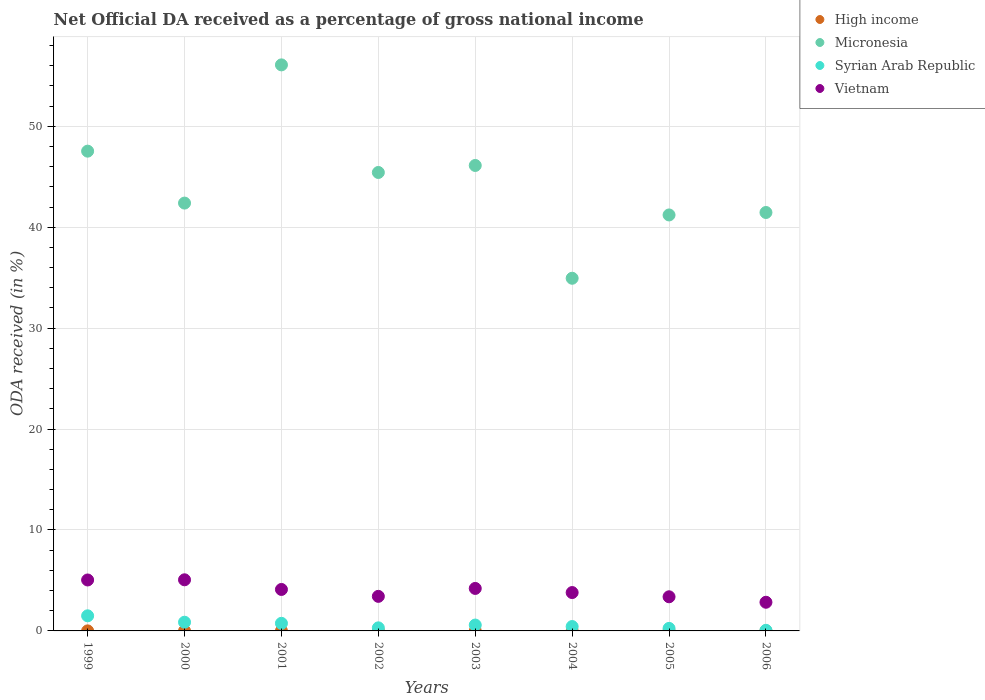Is the number of dotlines equal to the number of legend labels?
Ensure brevity in your answer.  Yes. What is the net official DA received in Syrian Arab Republic in 2002?
Make the answer very short. 0.3. Across all years, what is the maximum net official DA received in Vietnam?
Your response must be concise. 5.07. Across all years, what is the minimum net official DA received in Micronesia?
Give a very brief answer. 34.94. In which year was the net official DA received in High income minimum?
Your answer should be compact. 2005. What is the total net official DA received in Syrian Arab Republic in the graph?
Make the answer very short. 4.74. What is the difference between the net official DA received in Syrian Arab Republic in 2003 and that in 2004?
Make the answer very short. 0.15. What is the difference between the net official DA received in Vietnam in 2005 and the net official DA received in Syrian Arab Republic in 2000?
Keep it short and to the point. 2.52. What is the average net official DA received in Vietnam per year?
Your answer should be compact. 3.98. In the year 2000, what is the difference between the net official DA received in Micronesia and net official DA received in Vietnam?
Make the answer very short. 37.32. In how many years, is the net official DA received in Micronesia greater than 24 %?
Offer a very short reply. 8. What is the ratio of the net official DA received in Vietnam in 2001 to that in 2004?
Ensure brevity in your answer.  1.08. Is the net official DA received in Vietnam in 1999 less than that in 2005?
Give a very brief answer. No. What is the difference between the highest and the second highest net official DA received in Syrian Arab Republic?
Make the answer very short. 0.64. What is the difference between the highest and the lowest net official DA received in Micronesia?
Keep it short and to the point. 21.14. Is the sum of the net official DA received in Micronesia in 2000 and 2003 greater than the maximum net official DA received in Syrian Arab Republic across all years?
Make the answer very short. Yes. Is it the case that in every year, the sum of the net official DA received in High income and net official DA received in Micronesia  is greater than the sum of net official DA received in Syrian Arab Republic and net official DA received in Vietnam?
Ensure brevity in your answer.  Yes. Is the net official DA received in High income strictly greater than the net official DA received in Syrian Arab Republic over the years?
Offer a terse response. No. How many dotlines are there?
Provide a succinct answer. 4. How many years are there in the graph?
Make the answer very short. 8. What is the difference between two consecutive major ticks on the Y-axis?
Your response must be concise. 10. Are the values on the major ticks of Y-axis written in scientific E-notation?
Keep it short and to the point. No. Does the graph contain any zero values?
Your response must be concise. No. What is the title of the graph?
Give a very brief answer. Net Official DA received as a percentage of gross national income. What is the label or title of the X-axis?
Provide a succinct answer. Years. What is the label or title of the Y-axis?
Ensure brevity in your answer.  ODA received (in %). What is the ODA received (in %) of High income in 1999?
Your answer should be very brief. 0. What is the ODA received (in %) in Micronesia in 1999?
Provide a short and direct response. 47.54. What is the ODA received (in %) of Syrian Arab Republic in 1999?
Ensure brevity in your answer.  1.5. What is the ODA received (in %) of Vietnam in 1999?
Offer a terse response. 5.05. What is the ODA received (in %) in High income in 2000?
Ensure brevity in your answer.  0. What is the ODA received (in %) of Micronesia in 2000?
Keep it short and to the point. 42.39. What is the ODA received (in %) of Syrian Arab Republic in 2000?
Your answer should be compact. 0.86. What is the ODA received (in %) of Vietnam in 2000?
Offer a terse response. 5.07. What is the ODA received (in %) in High income in 2001?
Provide a short and direct response. 0. What is the ODA received (in %) in Micronesia in 2001?
Your answer should be very brief. 56.08. What is the ODA received (in %) in Syrian Arab Republic in 2001?
Your answer should be compact. 0.75. What is the ODA received (in %) in Vietnam in 2001?
Your answer should be compact. 4.11. What is the ODA received (in %) of High income in 2002?
Your answer should be compact. 0. What is the ODA received (in %) of Micronesia in 2002?
Keep it short and to the point. 45.42. What is the ODA received (in %) of Syrian Arab Republic in 2002?
Make the answer very short. 0.3. What is the ODA received (in %) of Vietnam in 2002?
Keep it short and to the point. 3.42. What is the ODA received (in %) of High income in 2003?
Your answer should be very brief. 0. What is the ODA received (in %) of Micronesia in 2003?
Your answer should be compact. 46.12. What is the ODA received (in %) of Syrian Arab Republic in 2003?
Offer a very short reply. 0.58. What is the ODA received (in %) of Vietnam in 2003?
Give a very brief answer. 4.21. What is the ODA received (in %) of High income in 2004?
Provide a succinct answer. 0. What is the ODA received (in %) in Micronesia in 2004?
Your answer should be compact. 34.94. What is the ODA received (in %) of Syrian Arab Republic in 2004?
Ensure brevity in your answer.  0.43. What is the ODA received (in %) of Vietnam in 2004?
Keep it short and to the point. 3.8. What is the ODA received (in %) of High income in 2005?
Give a very brief answer. 0. What is the ODA received (in %) in Micronesia in 2005?
Your answer should be very brief. 41.21. What is the ODA received (in %) of Syrian Arab Republic in 2005?
Your response must be concise. 0.25. What is the ODA received (in %) of Vietnam in 2005?
Make the answer very short. 3.38. What is the ODA received (in %) in High income in 2006?
Offer a very short reply. 0. What is the ODA received (in %) of Micronesia in 2006?
Offer a terse response. 41.46. What is the ODA received (in %) in Syrian Arab Republic in 2006?
Provide a short and direct response. 0.06. What is the ODA received (in %) of Vietnam in 2006?
Ensure brevity in your answer.  2.84. Across all years, what is the maximum ODA received (in %) of High income?
Your answer should be compact. 0. Across all years, what is the maximum ODA received (in %) of Micronesia?
Offer a very short reply. 56.08. Across all years, what is the maximum ODA received (in %) in Syrian Arab Republic?
Provide a short and direct response. 1.5. Across all years, what is the maximum ODA received (in %) in Vietnam?
Your response must be concise. 5.07. Across all years, what is the minimum ODA received (in %) of High income?
Your response must be concise. 0. Across all years, what is the minimum ODA received (in %) of Micronesia?
Give a very brief answer. 34.94. Across all years, what is the minimum ODA received (in %) in Syrian Arab Republic?
Keep it short and to the point. 0.06. Across all years, what is the minimum ODA received (in %) in Vietnam?
Your answer should be compact. 2.84. What is the total ODA received (in %) of High income in the graph?
Give a very brief answer. 0.01. What is the total ODA received (in %) of Micronesia in the graph?
Provide a short and direct response. 355.16. What is the total ODA received (in %) in Syrian Arab Republic in the graph?
Give a very brief answer. 4.74. What is the total ODA received (in %) in Vietnam in the graph?
Offer a terse response. 31.88. What is the difference between the ODA received (in %) in High income in 1999 and that in 2000?
Provide a short and direct response. 0. What is the difference between the ODA received (in %) in Micronesia in 1999 and that in 2000?
Offer a very short reply. 5.15. What is the difference between the ODA received (in %) of Syrian Arab Republic in 1999 and that in 2000?
Make the answer very short. 0.64. What is the difference between the ODA received (in %) of Vietnam in 1999 and that in 2000?
Make the answer very short. -0.02. What is the difference between the ODA received (in %) in High income in 1999 and that in 2001?
Ensure brevity in your answer.  0. What is the difference between the ODA received (in %) of Micronesia in 1999 and that in 2001?
Give a very brief answer. -8.55. What is the difference between the ODA received (in %) of Syrian Arab Republic in 1999 and that in 2001?
Your answer should be compact. 0.74. What is the difference between the ODA received (in %) of Vietnam in 1999 and that in 2001?
Offer a very short reply. 0.94. What is the difference between the ODA received (in %) of High income in 1999 and that in 2002?
Your response must be concise. 0. What is the difference between the ODA received (in %) in Micronesia in 1999 and that in 2002?
Your answer should be very brief. 2.11. What is the difference between the ODA received (in %) of Syrian Arab Republic in 1999 and that in 2002?
Keep it short and to the point. 1.19. What is the difference between the ODA received (in %) in Vietnam in 1999 and that in 2002?
Offer a terse response. 1.62. What is the difference between the ODA received (in %) in High income in 1999 and that in 2003?
Give a very brief answer. 0. What is the difference between the ODA received (in %) of Micronesia in 1999 and that in 2003?
Your response must be concise. 1.42. What is the difference between the ODA received (in %) in Syrian Arab Republic in 1999 and that in 2003?
Offer a terse response. 0.91. What is the difference between the ODA received (in %) of Vietnam in 1999 and that in 2003?
Ensure brevity in your answer.  0.84. What is the difference between the ODA received (in %) in High income in 1999 and that in 2004?
Provide a succinct answer. 0. What is the difference between the ODA received (in %) of Micronesia in 1999 and that in 2004?
Your answer should be compact. 12.59. What is the difference between the ODA received (in %) of Syrian Arab Republic in 1999 and that in 2004?
Ensure brevity in your answer.  1.06. What is the difference between the ODA received (in %) of Vietnam in 1999 and that in 2004?
Offer a very short reply. 1.25. What is the difference between the ODA received (in %) in High income in 1999 and that in 2005?
Your answer should be compact. 0. What is the difference between the ODA received (in %) in Micronesia in 1999 and that in 2005?
Offer a terse response. 6.32. What is the difference between the ODA received (in %) in Syrian Arab Republic in 1999 and that in 2005?
Your answer should be very brief. 1.25. What is the difference between the ODA received (in %) of Vietnam in 1999 and that in 2005?
Your answer should be compact. 1.67. What is the difference between the ODA received (in %) of High income in 1999 and that in 2006?
Your response must be concise. 0. What is the difference between the ODA received (in %) in Micronesia in 1999 and that in 2006?
Ensure brevity in your answer.  6.08. What is the difference between the ODA received (in %) of Syrian Arab Republic in 1999 and that in 2006?
Your answer should be very brief. 1.44. What is the difference between the ODA received (in %) in Vietnam in 1999 and that in 2006?
Provide a short and direct response. 2.21. What is the difference between the ODA received (in %) in High income in 2000 and that in 2001?
Provide a succinct answer. -0. What is the difference between the ODA received (in %) of Micronesia in 2000 and that in 2001?
Offer a terse response. -13.69. What is the difference between the ODA received (in %) in Syrian Arab Republic in 2000 and that in 2001?
Provide a succinct answer. 0.11. What is the difference between the ODA received (in %) in Vietnam in 2000 and that in 2001?
Your answer should be compact. 0.96. What is the difference between the ODA received (in %) of High income in 2000 and that in 2002?
Your response must be concise. 0. What is the difference between the ODA received (in %) in Micronesia in 2000 and that in 2002?
Ensure brevity in your answer.  -3.03. What is the difference between the ODA received (in %) in Syrian Arab Republic in 2000 and that in 2002?
Provide a short and direct response. 0.56. What is the difference between the ODA received (in %) of Vietnam in 2000 and that in 2002?
Your answer should be compact. 1.64. What is the difference between the ODA received (in %) in High income in 2000 and that in 2003?
Provide a succinct answer. -0. What is the difference between the ODA received (in %) in Micronesia in 2000 and that in 2003?
Give a very brief answer. -3.73. What is the difference between the ODA received (in %) in Syrian Arab Republic in 2000 and that in 2003?
Keep it short and to the point. 0.28. What is the difference between the ODA received (in %) of Vietnam in 2000 and that in 2003?
Provide a succinct answer. 0.86. What is the difference between the ODA received (in %) in High income in 2000 and that in 2004?
Make the answer very short. 0. What is the difference between the ODA received (in %) in Micronesia in 2000 and that in 2004?
Your response must be concise. 7.45. What is the difference between the ODA received (in %) of Syrian Arab Republic in 2000 and that in 2004?
Make the answer very short. 0.43. What is the difference between the ODA received (in %) of Vietnam in 2000 and that in 2004?
Provide a short and direct response. 1.26. What is the difference between the ODA received (in %) of Micronesia in 2000 and that in 2005?
Provide a short and direct response. 1.18. What is the difference between the ODA received (in %) of Syrian Arab Republic in 2000 and that in 2005?
Keep it short and to the point. 0.61. What is the difference between the ODA received (in %) of Vietnam in 2000 and that in 2005?
Make the answer very short. 1.68. What is the difference between the ODA received (in %) in Micronesia in 2000 and that in 2006?
Your answer should be compact. 0.93. What is the difference between the ODA received (in %) in Syrian Arab Republic in 2000 and that in 2006?
Your answer should be very brief. 0.8. What is the difference between the ODA received (in %) of Vietnam in 2000 and that in 2006?
Your answer should be compact. 2.23. What is the difference between the ODA received (in %) in High income in 2001 and that in 2002?
Provide a succinct answer. 0. What is the difference between the ODA received (in %) of Micronesia in 2001 and that in 2002?
Offer a very short reply. 10.66. What is the difference between the ODA received (in %) in Syrian Arab Republic in 2001 and that in 2002?
Your answer should be very brief. 0.45. What is the difference between the ODA received (in %) in Vietnam in 2001 and that in 2002?
Your answer should be compact. 0.68. What is the difference between the ODA received (in %) of High income in 2001 and that in 2003?
Provide a short and direct response. 0. What is the difference between the ODA received (in %) in Micronesia in 2001 and that in 2003?
Ensure brevity in your answer.  9.97. What is the difference between the ODA received (in %) in Syrian Arab Republic in 2001 and that in 2003?
Offer a terse response. 0.17. What is the difference between the ODA received (in %) in Vietnam in 2001 and that in 2003?
Provide a succinct answer. -0.1. What is the difference between the ODA received (in %) in High income in 2001 and that in 2004?
Keep it short and to the point. 0. What is the difference between the ODA received (in %) in Micronesia in 2001 and that in 2004?
Give a very brief answer. 21.14. What is the difference between the ODA received (in %) of Syrian Arab Republic in 2001 and that in 2004?
Give a very brief answer. 0.32. What is the difference between the ODA received (in %) in Vietnam in 2001 and that in 2004?
Your answer should be compact. 0.31. What is the difference between the ODA received (in %) of High income in 2001 and that in 2005?
Your answer should be very brief. 0. What is the difference between the ODA received (in %) of Micronesia in 2001 and that in 2005?
Give a very brief answer. 14.87. What is the difference between the ODA received (in %) in Syrian Arab Republic in 2001 and that in 2005?
Offer a terse response. 0.5. What is the difference between the ODA received (in %) in Vietnam in 2001 and that in 2005?
Make the answer very short. 0.73. What is the difference between the ODA received (in %) in High income in 2001 and that in 2006?
Keep it short and to the point. 0. What is the difference between the ODA received (in %) in Micronesia in 2001 and that in 2006?
Ensure brevity in your answer.  14.63. What is the difference between the ODA received (in %) of Syrian Arab Republic in 2001 and that in 2006?
Provide a succinct answer. 0.69. What is the difference between the ODA received (in %) of Vietnam in 2001 and that in 2006?
Your response must be concise. 1.27. What is the difference between the ODA received (in %) in High income in 2002 and that in 2003?
Your answer should be very brief. -0. What is the difference between the ODA received (in %) of Micronesia in 2002 and that in 2003?
Your answer should be compact. -0.69. What is the difference between the ODA received (in %) in Syrian Arab Republic in 2002 and that in 2003?
Your answer should be very brief. -0.28. What is the difference between the ODA received (in %) of Vietnam in 2002 and that in 2003?
Provide a short and direct response. -0.79. What is the difference between the ODA received (in %) in Micronesia in 2002 and that in 2004?
Provide a short and direct response. 10.48. What is the difference between the ODA received (in %) in Syrian Arab Republic in 2002 and that in 2004?
Your response must be concise. -0.13. What is the difference between the ODA received (in %) in Vietnam in 2002 and that in 2004?
Offer a very short reply. -0.38. What is the difference between the ODA received (in %) of High income in 2002 and that in 2005?
Provide a succinct answer. 0. What is the difference between the ODA received (in %) in Micronesia in 2002 and that in 2005?
Provide a succinct answer. 4.21. What is the difference between the ODA received (in %) of Syrian Arab Republic in 2002 and that in 2005?
Offer a terse response. 0.05. What is the difference between the ODA received (in %) in Vietnam in 2002 and that in 2005?
Your answer should be very brief. 0.04. What is the difference between the ODA received (in %) in Micronesia in 2002 and that in 2006?
Your answer should be very brief. 3.97. What is the difference between the ODA received (in %) of Syrian Arab Republic in 2002 and that in 2006?
Provide a short and direct response. 0.24. What is the difference between the ODA received (in %) of Vietnam in 2002 and that in 2006?
Offer a very short reply. 0.58. What is the difference between the ODA received (in %) in Micronesia in 2003 and that in 2004?
Ensure brevity in your answer.  11.18. What is the difference between the ODA received (in %) in Syrian Arab Republic in 2003 and that in 2004?
Your answer should be very brief. 0.15. What is the difference between the ODA received (in %) of Vietnam in 2003 and that in 2004?
Provide a short and direct response. 0.41. What is the difference between the ODA received (in %) in High income in 2003 and that in 2005?
Offer a terse response. 0. What is the difference between the ODA received (in %) in Micronesia in 2003 and that in 2005?
Give a very brief answer. 4.9. What is the difference between the ODA received (in %) in Syrian Arab Republic in 2003 and that in 2005?
Keep it short and to the point. 0.33. What is the difference between the ODA received (in %) of Vietnam in 2003 and that in 2005?
Give a very brief answer. 0.83. What is the difference between the ODA received (in %) in Micronesia in 2003 and that in 2006?
Offer a very short reply. 4.66. What is the difference between the ODA received (in %) of Syrian Arab Republic in 2003 and that in 2006?
Provide a short and direct response. 0.52. What is the difference between the ODA received (in %) in Vietnam in 2003 and that in 2006?
Give a very brief answer. 1.37. What is the difference between the ODA received (in %) in Micronesia in 2004 and that in 2005?
Your answer should be very brief. -6.27. What is the difference between the ODA received (in %) in Syrian Arab Republic in 2004 and that in 2005?
Make the answer very short. 0.18. What is the difference between the ODA received (in %) in Vietnam in 2004 and that in 2005?
Provide a short and direct response. 0.42. What is the difference between the ODA received (in %) of Micronesia in 2004 and that in 2006?
Ensure brevity in your answer.  -6.52. What is the difference between the ODA received (in %) in Syrian Arab Republic in 2004 and that in 2006?
Offer a terse response. 0.37. What is the difference between the ODA received (in %) of Vietnam in 2004 and that in 2006?
Provide a succinct answer. 0.96. What is the difference between the ODA received (in %) in High income in 2005 and that in 2006?
Give a very brief answer. -0. What is the difference between the ODA received (in %) of Micronesia in 2005 and that in 2006?
Give a very brief answer. -0.24. What is the difference between the ODA received (in %) of Syrian Arab Republic in 2005 and that in 2006?
Provide a succinct answer. 0.19. What is the difference between the ODA received (in %) of Vietnam in 2005 and that in 2006?
Keep it short and to the point. 0.54. What is the difference between the ODA received (in %) in High income in 1999 and the ODA received (in %) in Micronesia in 2000?
Ensure brevity in your answer.  -42.39. What is the difference between the ODA received (in %) in High income in 1999 and the ODA received (in %) in Syrian Arab Republic in 2000?
Provide a succinct answer. -0.86. What is the difference between the ODA received (in %) of High income in 1999 and the ODA received (in %) of Vietnam in 2000?
Your response must be concise. -5.06. What is the difference between the ODA received (in %) of Micronesia in 1999 and the ODA received (in %) of Syrian Arab Republic in 2000?
Provide a short and direct response. 46.67. What is the difference between the ODA received (in %) of Micronesia in 1999 and the ODA received (in %) of Vietnam in 2000?
Ensure brevity in your answer.  42.47. What is the difference between the ODA received (in %) in Syrian Arab Republic in 1999 and the ODA received (in %) in Vietnam in 2000?
Keep it short and to the point. -3.57. What is the difference between the ODA received (in %) of High income in 1999 and the ODA received (in %) of Micronesia in 2001?
Ensure brevity in your answer.  -56.08. What is the difference between the ODA received (in %) of High income in 1999 and the ODA received (in %) of Syrian Arab Republic in 2001?
Give a very brief answer. -0.75. What is the difference between the ODA received (in %) of High income in 1999 and the ODA received (in %) of Vietnam in 2001?
Offer a terse response. -4.1. What is the difference between the ODA received (in %) of Micronesia in 1999 and the ODA received (in %) of Syrian Arab Republic in 2001?
Give a very brief answer. 46.78. What is the difference between the ODA received (in %) of Micronesia in 1999 and the ODA received (in %) of Vietnam in 2001?
Your response must be concise. 43.43. What is the difference between the ODA received (in %) of Syrian Arab Republic in 1999 and the ODA received (in %) of Vietnam in 2001?
Offer a terse response. -2.61. What is the difference between the ODA received (in %) of High income in 1999 and the ODA received (in %) of Micronesia in 2002?
Offer a very short reply. -45.42. What is the difference between the ODA received (in %) in High income in 1999 and the ODA received (in %) in Syrian Arab Republic in 2002?
Offer a very short reply. -0.3. What is the difference between the ODA received (in %) of High income in 1999 and the ODA received (in %) of Vietnam in 2002?
Offer a terse response. -3.42. What is the difference between the ODA received (in %) in Micronesia in 1999 and the ODA received (in %) in Syrian Arab Republic in 2002?
Your answer should be very brief. 47.23. What is the difference between the ODA received (in %) of Micronesia in 1999 and the ODA received (in %) of Vietnam in 2002?
Give a very brief answer. 44.11. What is the difference between the ODA received (in %) in Syrian Arab Republic in 1999 and the ODA received (in %) in Vietnam in 2002?
Your response must be concise. -1.93. What is the difference between the ODA received (in %) in High income in 1999 and the ODA received (in %) in Micronesia in 2003?
Your response must be concise. -46.11. What is the difference between the ODA received (in %) in High income in 1999 and the ODA received (in %) in Syrian Arab Republic in 2003?
Your response must be concise. -0.58. What is the difference between the ODA received (in %) in High income in 1999 and the ODA received (in %) in Vietnam in 2003?
Offer a terse response. -4.21. What is the difference between the ODA received (in %) of Micronesia in 1999 and the ODA received (in %) of Syrian Arab Republic in 2003?
Provide a short and direct response. 46.95. What is the difference between the ODA received (in %) in Micronesia in 1999 and the ODA received (in %) in Vietnam in 2003?
Your answer should be compact. 43.33. What is the difference between the ODA received (in %) in Syrian Arab Republic in 1999 and the ODA received (in %) in Vietnam in 2003?
Provide a short and direct response. -2.71. What is the difference between the ODA received (in %) of High income in 1999 and the ODA received (in %) of Micronesia in 2004?
Provide a succinct answer. -34.94. What is the difference between the ODA received (in %) of High income in 1999 and the ODA received (in %) of Syrian Arab Republic in 2004?
Keep it short and to the point. -0.43. What is the difference between the ODA received (in %) in High income in 1999 and the ODA received (in %) in Vietnam in 2004?
Your answer should be compact. -3.8. What is the difference between the ODA received (in %) of Micronesia in 1999 and the ODA received (in %) of Syrian Arab Republic in 2004?
Ensure brevity in your answer.  47.1. What is the difference between the ODA received (in %) in Micronesia in 1999 and the ODA received (in %) in Vietnam in 2004?
Keep it short and to the point. 43.73. What is the difference between the ODA received (in %) in Syrian Arab Republic in 1999 and the ODA received (in %) in Vietnam in 2004?
Offer a terse response. -2.3. What is the difference between the ODA received (in %) in High income in 1999 and the ODA received (in %) in Micronesia in 2005?
Your response must be concise. -41.21. What is the difference between the ODA received (in %) in High income in 1999 and the ODA received (in %) in Syrian Arab Republic in 2005?
Offer a very short reply. -0.25. What is the difference between the ODA received (in %) of High income in 1999 and the ODA received (in %) of Vietnam in 2005?
Offer a terse response. -3.38. What is the difference between the ODA received (in %) in Micronesia in 1999 and the ODA received (in %) in Syrian Arab Republic in 2005?
Your answer should be compact. 47.28. What is the difference between the ODA received (in %) in Micronesia in 1999 and the ODA received (in %) in Vietnam in 2005?
Offer a very short reply. 44.15. What is the difference between the ODA received (in %) in Syrian Arab Republic in 1999 and the ODA received (in %) in Vietnam in 2005?
Provide a succinct answer. -1.89. What is the difference between the ODA received (in %) in High income in 1999 and the ODA received (in %) in Micronesia in 2006?
Provide a short and direct response. -41.45. What is the difference between the ODA received (in %) in High income in 1999 and the ODA received (in %) in Syrian Arab Republic in 2006?
Your answer should be very brief. -0.06. What is the difference between the ODA received (in %) of High income in 1999 and the ODA received (in %) of Vietnam in 2006?
Offer a terse response. -2.84. What is the difference between the ODA received (in %) in Micronesia in 1999 and the ODA received (in %) in Syrian Arab Republic in 2006?
Offer a very short reply. 47.48. What is the difference between the ODA received (in %) in Micronesia in 1999 and the ODA received (in %) in Vietnam in 2006?
Your response must be concise. 44.7. What is the difference between the ODA received (in %) in Syrian Arab Republic in 1999 and the ODA received (in %) in Vietnam in 2006?
Make the answer very short. -1.34. What is the difference between the ODA received (in %) in High income in 2000 and the ODA received (in %) in Micronesia in 2001?
Make the answer very short. -56.08. What is the difference between the ODA received (in %) in High income in 2000 and the ODA received (in %) in Syrian Arab Republic in 2001?
Provide a short and direct response. -0.75. What is the difference between the ODA received (in %) of High income in 2000 and the ODA received (in %) of Vietnam in 2001?
Provide a short and direct response. -4.11. What is the difference between the ODA received (in %) of Micronesia in 2000 and the ODA received (in %) of Syrian Arab Republic in 2001?
Provide a succinct answer. 41.64. What is the difference between the ODA received (in %) in Micronesia in 2000 and the ODA received (in %) in Vietnam in 2001?
Ensure brevity in your answer.  38.28. What is the difference between the ODA received (in %) of Syrian Arab Republic in 2000 and the ODA received (in %) of Vietnam in 2001?
Make the answer very short. -3.25. What is the difference between the ODA received (in %) of High income in 2000 and the ODA received (in %) of Micronesia in 2002?
Offer a very short reply. -45.42. What is the difference between the ODA received (in %) of High income in 2000 and the ODA received (in %) of Syrian Arab Republic in 2002?
Your answer should be very brief. -0.3. What is the difference between the ODA received (in %) of High income in 2000 and the ODA received (in %) of Vietnam in 2002?
Offer a very short reply. -3.42. What is the difference between the ODA received (in %) of Micronesia in 2000 and the ODA received (in %) of Syrian Arab Republic in 2002?
Make the answer very short. 42.09. What is the difference between the ODA received (in %) of Micronesia in 2000 and the ODA received (in %) of Vietnam in 2002?
Your answer should be compact. 38.97. What is the difference between the ODA received (in %) in Syrian Arab Republic in 2000 and the ODA received (in %) in Vietnam in 2002?
Offer a very short reply. -2.56. What is the difference between the ODA received (in %) of High income in 2000 and the ODA received (in %) of Micronesia in 2003?
Your answer should be very brief. -46.12. What is the difference between the ODA received (in %) in High income in 2000 and the ODA received (in %) in Syrian Arab Republic in 2003?
Make the answer very short. -0.58. What is the difference between the ODA received (in %) in High income in 2000 and the ODA received (in %) in Vietnam in 2003?
Keep it short and to the point. -4.21. What is the difference between the ODA received (in %) of Micronesia in 2000 and the ODA received (in %) of Syrian Arab Republic in 2003?
Keep it short and to the point. 41.81. What is the difference between the ODA received (in %) of Micronesia in 2000 and the ODA received (in %) of Vietnam in 2003?
Provide a succinct answer. 38.18. What is the difference between the ODA received (in %) in Syrian Arab Republic in 2000 and the ODA received (in %) in Vietnam in 2003?
Your answer should be compact. -3.35. What is the difference between the ODA received (in %) in High income in 2000 and the ODA received (in %) in Micronesia in 2004?
Offer a terse response. -34.94. What is the difference between the ODA received (in %) of High income in 2000 and the ODA received (in %) of Syrian Arab Republic in 2004?
Keep it short and to the point. -0.43. What is the difference between the ODA received (in %) of High income in 2000 and the ODA received (in %) of Vietnam in 2004?
Make the answer very short. -3.8. What is the difference between the ODA received (in %) in Micronesia in 2000 and the ODA received (in %) in Syrian Arab Republic in 2004?
Make the answer very short. 41.96. What is the difference between the ODA received (in %) in Micronesia in 2000 and the ODA received (in %) in Vietnam in 2004?
Keep it short and to the point. 38.59. What is the difference between the ODA received (in %) of Syrian Arab Republic in 2000 and the ODA received (in %) of Vietnam in 2004?
Your answer should be very brief. -2.94. What is the difference between the ODA received (in %) of High income in 2000 and the ODA received (in %) of Micronesia in 2005?
Your answer should be compact. -41.21. What is the difference between the ODA received (in %) of High income in 2000 and the ODA received (in %) of Syrian Arab Republic in 2005?
Give a very brief answer. -0.25. What is the difference between the ODA received (in %) of High income in 2000 and the ODA received (in %) of Vietnam in 2005?
Keep it short and to the point. -3.38. What is the difference between the ODA received (in %) of Micronesia in 2000 and the ODA received (in %) of Syrian Arab Republic in 2005?
Give a very brief answer. 42.14. What is the difference between the ODA received (in %) in Micronesia in 2000 and the ODA received (in %) in Vietnam in 2005?
Give a very brief answer. 39.01. What is the difference between the ODA received (in %) in Syrian Arab Republic in 2000 and the ODA received (in %) in Vietnam in 2005?
Offer a terse response. -2.52. What is the difference between the ODA received (in %) of High income in 2000 and the ODA received (in %) of Micronesia in 2006?
Provide a short and direct response. -41.46. What is the difference between the ODA received (in %) in High income in 2000 and the ODA received (in %) in Syrian Arab Republic in 2006?
Offer a very short reply. -0.06. What is the difference between the ODA received (in %) in High income in 2000 and the ODA received (in %) in Vietnam in 2006?
Offer a very short reply. -2.84. What is the difference between the ODA received (in %) of Micronesia in 2000 and the ODA received (in %) of Syrian Arab Republic in 2006?
Give a very brief answer. 42.33. What is the difference between the ODA received (in %) of Micronesia in 2000 and the ODA received (in %) of Vietnam in 2006?
Offer a very short reply. 39.55. What is the difference between the ODA received (in %) of Syrian Arab Republic in 2000 and the ODA received (in %) of Vietnam in 2006?
Offer a very short reply. -1.98. What is the difference between the ODA received (in %) of High income in 2001 and the ODA received (in %) of Micronesia in 2002?
Provide a succinct answer. -45.42. What is the difference between the ODA received (in %) in High income in 2001 and the ODA received (in %) in Syrian Arab Republic in 2002?
Ensure brevity in your answer.  -0.3. What is the difference between the ODA received (in %) in High income in 2001 and the ODA received (in %) in Vietnam in 2002?
Keep it short and to the point. -3.42. What is the difference between the ODA received (in %) of Micronesia in 2001 and the ODA received (in %) of Syrian Arab Republic in 2002?
Ensure brevity in your answer.  55.78. What is the difference between the ODA received (in %) in Micronesia in 2001 and the ODA received (in %) in Vietnam in 2002?
Your answer should be very brief. 52.66. What is the difference between the ODA received (in %) in Syrian Arab Republic in 2001 and the ODA received (in %) in Vietnam in 2002?
Offer a terse response. -2.67. What is the difference between the ODA received (in %) of High income in 2001 and the ODA received (in %) of Micronesia in 2003?
Ensure brevity in your answer.  -46.12. What is the difference between the ODA received (in %) in High income in 2001 and the ODA received (in %) in Syrian Arab Republic in 2003?
Keep it short and to the point. -0.58. What is the difference between the ODA received (in %) of High income in 2001 and the ODA received (in %) of Vietnam in 2003?
Offer a terse response. -4.21. What is the difference between the ODA received (in %) of Micronesia in 2001 and the ODA received (in %) of Syrian Arab Republic in 2003?
Provide a succinct answer. 55.5. What is the difference between the ODA received (in %) of Micronesia in 2001 and the ODA received (in %) of Vietnam in 2003?
Offer a terse response. 51.87. What is the difference between the ODA received (in %) in Syrian Arab Republic in 2001 and the ODA received (in %) in Vietnam in 2003?
Provide a short and direct response. -3.46. What is the difference between the ODA received (in %) of High income in 2001 and the ODA received (in %) of Micronesia in 2004?
Offer a terse response. -34.94. What is the difference between the ODA received (in %) in High income in 2001 and the ODA received (in %) in Syrian Arab Republic in 2004?
Your answer should be compact. -0.43. What is the difference between the ODA received (in %) of High income in 2001 and the ODA received (in %) of Vietnam in 2004?
Your response must be concise. -3.8. What is the difference between the ODA received (in %) of Micronesia in 2001 and the ODA received (in %) of Syrian Arab Republic in 2004?
Your answer should be very brief. 55.65. What is the difference between the ODA received (in %) of Micronesia in 2001 and the ODA received (in %) of Vietnam in 2004?
Ensure brevity in your answer.  52.28. What is the difference between the ODA received (in %) in Syrian Arab Republic in 2001 and the ODA received (in %) in Vietnam in 2004?
Ensure brevity in your answer.  -3.05. What is the difference between the ODA received (in %) in High income in 2001 and the ODA received (in %) in Micronesia in 2005?
Your response must be concise. -41.21. What is the difference between the ODA received (in %) in High income in 2001 and the ODA received (in %) in Syrian Arab Republic in 2005?
Give a very brief answer. -0.25. What is the difference between the ODA received (in %) of High income in 2001 and the ODA received (in %) of Vietnam in 2005?
Your answer should be very brief. -3.38. What is the difference between the ODA received (in %) of Micronesia in 2001 and the ODA received (in %) of Syrian Arab Republic in 2005?
Give a very brief answer. 55.83. What is the difference between the ODA received (in %) in Micronesia in 2001 and the ODA received (in %) in Vietnam in 2005?
Keep it short and to the point. 52.7. What is the difference between the ODA received (in %) in Syrian Arab Republic in 2001 and the ODA received (in %) in Vietnam in 2005?
Keep it short and to the point. -2.63. What is the difference between the ODA received (in %) in High income in 2001 and the ODA received (in %) in Micronesia in 2006?
Provide a short and direct response. -41.46. What is the difference between the ODA received (in %) in High income in 2001 and the ODA received (in %) in Syrian Arab Republic in 2006?
Your answer should be compact. -0.06. What is the difference between the ODA received (in %) in High income in 2001 and the ODA received (in %) in Vietnam in 2006?
Provide a short and direct response. -2.84. What is the difference between the ODA received (in %) of Micronesia in 2001 and the ODA received (in %) of Syrian Arab Republic in 2006?
Offer a terse response. 56.02. What is the difference between the ODA received (in %) of Micronesia in 2001 and the ODA received (in %) of Vietnam in 2006?
Keep it short and to the point. 53.24. What is the difference between the ODA received (in %) of Syrian Arab Republic in 2001 and the ODA received (in %) of Vietnam in 2006?
Offer a terse response. -2.09. What is the difference between the ODA received (in %) in High income in 2002 and the ODA received (in %) in Micronesia in 2003?
Give a very brief answer. -46.12. What is the difference between the ODA received (in %) of High income in 2002 and the ODA received (in %) of Syrian Arab Republic in 2003?
Provide a short and direct response. -0.58. What is the difference between the ODA received (in %) in High income in 2002 and the ODA received (in %) in Vietnam in 2003?
Give a very brief answer. -4.21. What is the difference between the ODA received (in %) of Micronesia in 2002 and the ODA received (in %) of Syrian Arab Republic in 2003?
Give a very brief answer. 44.84. What is the difference between the ODA received (in %) of Micronesia in 2002 and the ODA received (in %) of Vietnam in 2003?
Keep it short and to the point. 41.21. What is the difference between the ODA received (in %) of Syrian Arab Republic in 2002 and the ODA received (in %) of Vietnam in 2003?
Provide a short and direct response. -3.91. What is the difference between the ODA received (in %) of High income in 2002 and the ODA received (in %) of Micronesia in 2004?
Offer a very short reply. -34.94. What is the difference between the ODA received (in %) of High income in 2002 and the ODA received (in %) of Syrian Arab Republic in 2004?
Give a very brief answer. -0.43. What is the difference between the ODA received (in %) of High income in 2002 and the ODA received (in %) of Vietnam in 2004?
Provide a short and direct response. -3.8. What is the difference between the ODA received (in %) of Micronesia in 2002 and the ODA received (in %) of Syrian Arab Republic in 2004?
Provide a short and direct response. 44.99. What is the difference between the ODA received (in %) in Micronesia in 2002 and the ODA received (in %) in Vietnam in 2004?
Your response must be concise. 41.62. What is the difference between the ODA received (in %) of Syrian Arab Republic in 2002 and the ODA received (in %) of Vietnam in 2004?
Make the answer very short. -3.5. What is the difference between the ODA received (in %) of High income in 2002 and the ODA received (in %) of Micronesia in 2005?
Give a very brief answer. -41.21. What is the difference between the ODA received (in %) of High income in 2002 and the ODA received (in %) of Syrian Arab Republic in 2005?
Provide a short and direct response. -0.25. What is the difference between the ODA received (in %) of High income in 2002 and the ODA received (in %) of Vietnam in 2005?
Your response must be concise. -3.38. What is the difference between the ODA received (in %) in Micronesia in 2002 and the ODA received (in %) in Syrian Arab Republic in 2005?
Keep it short and to the point. 45.17. What is the difference between the ODA received (in %) in Micronesia in 2002 and the ODA received (in %) in Vietnam in 2005?
Give a very brief answer. 42.04. What is the difference between the ODA received (in %) in Syrian Arab Republic in 2002 and the ODA received (in %) in Vietnam in 2005?
Keep it short and to the point. -3.08. What is the difference between the ODA received (in %) in High income in 2002 and the ODA received (in %) in Micronesia in 2006?
Ensure brevity in your answer.  -41.46. What is the difference between the ODA received (in %) of High income in 2002 and the ODA received (in %) of Syrian Arab Republic in 2006?
Offer a terse response. -0.06. What is the difference between the ODA received (in %) in High income in 2002 and the ODA received (in %) in Vietnam in 2006?
Your answer should be very brief. -2.84. What is the difference between the ODA received (in %) of Micronesia in 2002 and the ODA received (in %) of Syrian Arab Republic in 2006?
Ensure brevity in your answer.  45.36. What is the difference between the ODA received (in %) in Micronesia in 2002 and the ODA received (in %) in Vietnam in 2006?
Your response must be concise. 42.58. What is the difference between the ODA received (in %) in Syrian Arab Republic in 2002 and the ODA received (in %) in Vietnam in 2006?
Make the answer very short. -2.54. What is the difference between the ODA received (in %) of High income in 2003 and the ODA received (in %) of Micronesia in 2004?
Ensure brevity in your answer.  -34.94. What is the difference between the ODA received (in %) in High income in 2003 and the ODA received (in %) in Syrian Arab Republic in 2004?
Make the answer very short. -0.43. What is the difference between the ODA received (in %) of High income in 2003 and the ODA received (in %) of Vietnam in 2004?
Offer a terse response. -3.8. What is the difference between the ODA received (in %) in Micronesia in 2003 and the ODA received (in %) in Syrian Arab Republic in 2004?
Ensure brevity in your answer.  45.68. What is the difference between the ODA received (in %) in Micronesia in 2003 and the ODA received (in %) in Vietnam in 2004?
Provide a succinct answer. 42.32. What is the difference between the ODA received (in %) of Syrian Arab Republic in 2003 and the ODA received (in %) of Vietnam in 2004?
Provide a succinct answer. -3.22. What is the difference between the ODA received (in %) of High income in 2003 and the ODA received (in %) of Micronesia in 2005?
Provide a short and direct response. -41.21. What is the difference between the ODA received (in %) of High income in 2003 and the ODA received (in %) of Syrian Arab Republic in 2005?
Your answer should be compact. -0.25. What is the difference between the ODA received (in %) of High income in 2003 and the ODA received (in %) of Vietnam in 2005?
Ensure brevity in your answer.  -3.38. What is the difference between the ODA received (in %) in Micronesia in 2003 and the ODA received (in %) in Syrian Arab Republic in 2005?
Give a very brief answer. 45.87. What is the difference between the ODA received (in %) of Micronesia in 2003 and the ODA received (in %) of Vietnam in 2005?
Your answer should be compact. 42.74. What is the difference between the ODA received (in %) in Syrian Arab Republic in 2003 and the ODA received (in %) in Vietnam in 2005?
Your answer should be very brief. -2.8. What is the difference between the ODA received (in %) of High income in 2003 and the ODA received (in %) of Micronesia in 2006?
Make the answer very short. -41.46. What is the difference between the ODA received (in %) of High income in 2003 and the ODA received (in %) of Syrian Arab Republic in 2006?
Ensure brevity in your answer.  -0.06. What is the difference between the ODA received (in %) of High income in 2003 and the ODA received (in %) of Vietnam in 2006?
Your response must be concise. -2.84. What is the difference between the ODA received (in %) of Micronesia in 2003 and the ODA received (in %) of Syrian Arab Republic in 2006?
Keep it short and to the point. 46.06. What is the difference between the ODA received (in %) in Micronesia in 2003 and the ODA received (in %) in Vietnam in 2006?
Provide a succinct answer. 43.28. What is the difference between the ODA received (in %) of Syrian Arab Republic in 2003 and the ODA received (in %) of Vietnam in 2006?
Offer a terse response. -2.26. What is the difference between the ODA received (in %) of High income in 2004 and the ODA received (in %) of Micronesia in 2005?
Keep it short and to the point. -41.21. What is the difference between the ODA received (in %) in High income in 2004 and the ODA received (in %) in Syrian Arab Republic in 2005?
Provide a short and direct response. -0.25. What is the difference between the ODA received (in %) in High income in 2004 and the ODA received (in %) in Vietnam in 2005?
Keep it short and to the point. -3.38. What is the difference between the ODA received (in %) in Micronesia in 2004 and the ODA received (in %) in Syrian Arab Republic in 2005?
Your answer should be very brief. 34.69. What is the difference between the ODA received (in %) in Micronesia in 2004 and the ODA received (in %) in Vietnam in 2005?
Keep it short and to the point. 31.56. What is the difference between the ODA received (in %) in Syrian Arab Republic in 2004 and the ODA received (in %) in Vietnam in 2005?
Keep it short and to the point. -2.95. What is the difference between the ODA received (in %) in High income in 2004 and the ODA received (in %) in Micronesia in 2006?
Your answer should be very brief. -41.46. What is the difference between the ODA received (in %) in High income in 2004 and the ODA received (in %) in Syrian Arab Republic in 2006?
Your answer should be very brief. -0.06. What is the difference between the ODA received (in %) in High income in 2004 and the ODA received (in %) in Vietnam in 2006?
Ensure brevity in your answer.  -2.84. What is the difference between the ODA received (in %) in Micronesia in 2004 and the ODA received (in %) in Syrian Arab Republic in 2006?
Keep it short and to the point. 34.88. What is the difference between the ODA received (in %) of Micronesia in 2004 and the ODA received (in %) of Vietnam in 2006?
Provide a succinct answer. 32.1. What is the difference between the ODA received (in %) of Syrian Arab Republic in 2004 and the ODA received (in %) of Vietnam in 2006?
Provide a succinct answer. -2.41. What is the difference between the ODA received (in %) in High income in 2005 and the ODA received (in %) in Micronesia in 2006?
Your response must be concise. -41.46. What is the difference between the ODA received (in %) of High income in 2005 and the ODA received (in %) of Syrian Arab Republic in 2006?
Offer a terse response. -0.06. What is the difference between the ODA received (in %) in High income in 2005 and the ODA received (in %) in Vietnam in 2006?
Keep it short and to the point. -2.84. What is the difference between the ODA received (in %) of Micronesia in 2005 and the ODA received (in %) of Syrian Arab Republic in 2006?
Provide a short and direct response. 41.16. What is the difference between the ODA received (in %) in Micronesia in 2005 and the ODA received (in %) in Vietnam in 2006?
Keep it short and to the point. 38.37. What is the difference between the ODA received (in %) of Syrian Arab Republic in 2005 and the ODA received (in %) of Vietnam in 2006?
Your answer should be compact. -2.59. What is the average ODA received (in %) in High income per year?
Keep it short and to the point. 0. What is the average ODA received (in %) of Micronesia per year?
Your answer should be very brief. 44.4. What is the average ODA received (in %) in Syrian Arab Republic per year?
Provide a short and direct response. 0.59. What is the average ODA received (in %) in Vietnam per year?
Keep it short and to the point. 3.98. In the year 1999, what is the difference between the ODA received (in %) in High income and ODA received (in %) in Micronesia?
Your answer should be compact. -47.53. In the year 1999, what is the difference between the ODA received (in %) of High income and ODA received (in %) of Syrian Arab Republic?
Make the answer very short. -1.49. In the year 1999, what is the difference between the ODA received (in %) of High income and ODA received (in %) of Vietnam?
Ensure brevity in your answer.  -5.04. In the year 1999, what is the difference between the ODA received (in %) of Micronesia and ODA received (in %) of Syrian Arab Republic?
Provide a succinct answer. 46.04. In the year 1999, what is the difference between the ODA received (in %) in Micronesia and ODA received (in %) in Vietnam?
Provide a short and direct response. 42.49. In the year 1999, what is the difference between the ODA received (in %) in Syrian Arab Republic and ODA received (in %) in Vietnam?
Ensure brevity in your answer.  -3.55. In the year 2000, what is the difference between the ODA received (in %) in High income and ODA received (in %) in Micronesia?
Provide a short and direct response. -42.39. In the year 2000, what is the difference between the ODA received (in %) of High income and ODA received (in %) of Syrian Arab Republic?
Keep it short and to the point. -0.86. In the year 2000, what is the difference between the ODA received (in %) of High income and ODA received (in %) of Vietnam?
Your response must be concise. -5.06. In the year 2000, what is the difference between the ODA received (in %) of Micronesia and ODA received (in %) of Syrian Arab Republic?
Offer a very short reply. 41.53. In the year 2000, what is the difference between the ODA received (in %) of Micronesia and ODA received (in %) of Vietnam?
Make the answer very short. 37.32. In the year 2000, what is the difference between the ODA received (in %) of Syrian Arab Republic and ODA received (in %) of Vietnam?
Offer a terse response. -4.2. In the year 2001, what is the difference between the ODA received (in %) of High income and ODA received (in %) of Micronesia?
Your answer should be very brief. -56.08. In the year 2001, what is the difference between the ODA received (in %) in High income and ODA received (in %) in Syrian Arab Republic?
Ensure brevity in your answer.  -0.75. In the year 2001, what is the difference between the ODA received (in %) of High income and ODA received (in %) of Vietnam?
Ensure brevity in your answer.  -4.11. In the year 2001, what is the difference between the ODA received (in %) of Micronesia and ODA received (in %) of Syrian Arab Republic?
Give a very brief answer. 55.33. In the year 2001, what is the difference between the ODA received (in %) in Micronesia and ODA received (in %) in Vietnam?
Keep it short and to the point. 51.98. In the year 2001, what is the difference between the ODA received (in %) of Syrian Arab Republic and ODA received (in %) of Vietnam?
Provide a short and direct response. -3.36. In the year 2002, what is the difference between the ODA received (in %) in High income and ODA received (in %) in Micronesia?
Your answer should be compact. -45.42. In the year 2002, what is the difference between the ODA received (in %) of High income and ODA received (in %) of Syrian Arab Republic?
Give a very brief answer. -0.3. In the year 2002, what is the difference between the ODA received (in %) of High income and ODA received (in %) of Vietnam?
Keep it short and to the point. -3.42. In the year 2002, what is the difference between the ODA received (in %) in Micronesia and ODA received (in %) in Syrian Arab Republic?
Make the answer very short. 45.12. In the year 2002, what is the difference between the ODA received (in %) in Micronesia and ODA received (in %) in Vietnam?
Provide a short and direct response. 42. In the year 2002, what is the difference between the ODA received (in %) in Syrian Arab Republic and ODA received (in %) in Vietnam?
Your answer should be very brief. -3.12. In the year 2003, what is the difference between the ODA received (in %) of High income and ODA received (in %) of Micronesia?
Your response must be concise. -46.12. In the year 2003, what is the difference between the ODA received (in %) in High income and ODA received (in %) in Syrian Arab Republic?
Ensure brevity in your answer.  -0.58. In the year 2003, what is the difference between the ODA received (in %) of High income and ODA received (in %) of Vietnam?
Your answer should be very brief. -4.21. In the year 2003, what is the difference between the ODA received (in %) in Micronesia and ODA received (in %) in Syrian Arab Republic?
Offer a very short reply. 45.54. In the year 2003, what is the difference between the ODA received (in %) in Micronesia and ODA received (in %) in Vietnam?
Your response must be concise. 41.91. In the year 2003, what is the difference between the ODA received (in %) of Syrian Arab Republic and ODA received (in %) of Vietnam?
Make the answer very short. -3.63. In the year 2004, what is the difference between the ODA received (in %) in High income and ODA received (in %) in Micronesia?
Offer a terse response. -34.94. In the year 2004, what is the difference between the ODA received (in %) of High income and ODA received (in %) of Syrian Arab Republic?
Keep it short and to the point. -0.43. In the year 2004, what is the difference between the ODA received (in %) of High income and ODA received (in %) of Vietnam?
Keep it short and to the point. -3.8. In the year 2004, what is the difference between the ODA received (in %) in Micronesia and ODA received (in %) in Syrian Arab Republic?
Keep it short and to the point. 34.51. In the year 2004, what is the difference between the ODA received (in %) in Micronesia and ODA received (in %) in Vietnam?
Ensure brevity in your answer.  31.14. In the year 2004, what is the difference between the ODA received (in %) of Syrian Arab Republic and ODA received (in %) of Vietnam?
Provide a short and direct response. -3.37. In the year 2005, what is the difference between the ODA received (in %) of High income and ODA received (in %) of Micronesia?
Make the answer very short. -41.21. In the year 2005, what is the difference between the ODA received (in %) in High income and ODA received (in %) in Syrian Arab Republic?
Offer a terse response. -0.25. In the year 2005, what is the difference between the ODA received (in %) in High income and ODA received (in %) in Vietnam?
Give a very brief answer. -3.38. In the year 2005, what is the difference between the ODA received (in %) of Micronesia and ODA received (in %) of Syrian Arab Republic?
Give a very brief answer. 40.96. In the year 2005, what is the difference between the ODA received (in %) in Micronesia and ODA received (in %) in Vietnam?
Offer a terse response. 37.83. In the year 2005, what is the difference between the ODA received (in %) of Syrian Arab Republic and ODA received (in %) of Vietnam?
Give a very brief answer. -3.13. In the year 2006, what is the difference between the ODA received (in %) of High income and ODA received (in %) of Micronesia?
Provide a short and direct response. -41.46. In the year 2006, what is the difference between the ODA received (in %) in High income and ODA received (in %) in Syrian Arab Republic?
Ensure brevity in your answer.  -0.06. In the year 2006, what is the difference between the ODA received (in %) in High income and ODA received (in %) in Vietnam?
Offer a terse response. -2.84. In the year 2006, what is the difference between the ODA received (in %) in Micronesia and ODA received (in %) in Syrian Arab Republic?
Give a very brief answer. 41.4. In the year 2006, what is the difference between the ODA received (in %) in Micronesia and ODA received (in %) in Vietnam?
Offer a very short reply. 38.62. In the year 2006, what is the difference between the ODA received (in %) of Syrian Arab Republic and ODA received (in %) of Vietnam?
Give a very brief answer. -2.78. What is the ratio of the ODA received (in %) in High income in 1999 to that in 2000?
Keep it short and to the point. 2.78. What is the ratio of the ODA received (in %) in Micronesia in 1999 to that in 2000?
Offer a very short reply. 1.12. What is the ratio of the ODA received (in %) of Syrian Arab Republic in 1999 to that in 2000?
Provide a succinct answer. 1.74. What is the ratio of the ODA received (in %) of Vietnam in 1999 to that in 2000?
Provide a short and direct response. 1. What is the ratio of the ODA received (in %) in High income in 1999 to that in 2001?
Keep it short and to the point. 2.45. What is the ratio of the ODA received (in %) of Micronesia in 1999 to that in 2001?
Make the answer very short. 0.85. What is the ratio of the ODA received (in %) in Syrian Arab Republic in 1999 to that in 2001?
Offer a very short reply. 1.99. What is the ratio of the ODA received (in %) in Vietnam in 1999 to that in 2001?
Give a very brief answer. 1.23. What is the ratio of the ODA received (in %) of High income in 1999 to that in 2002?
Ensure brevity in your answer.  2.78. What is the ratio of the ODA received (in %) in Micronesia in 1999 to that in 2002?
Offer a terse response. 1.05. What is the ratio of the ODA received (in %) of Syrian Arab Republic in 1999 to that in 2002?
Keep it short and to the point. 4.92. What is the ratio of the ODA received (in %) of Vietnam in 1999 to that in 2002?
Offer a terse response. 1.47. What is the ratio of the ODA received (in %) in High income in 1999 to that in 2003?
Provide a succinct answer. 2.74. What is the ratio of the ODA received (in %) in Micronesia in 1999 to that in 2003?
Your response must be concise. 1.03. What is the ratio of the ODA received (in %) in Syrian Arab Republic in 1999 to that in 2003?
Ensure brevity in your answer.  2.57. What is the ratio of the ODA received (in %) of Vietnam in 1999 to that in 2003?
Your answer should be compact. 1.2. What is the ratio of the ODA received (in %) of High income in 1999 to that in 2004?
Your answer should be compact. 3.37. What is the ratio of the ODA received (in %) in Micronesia in 1999 to that in 2004?
Give a very brief answer. 1.36. What is the ratio of the ODA received (in %) of Syrian Arab Republic in 1999 to that in 2004?
Make the answer very short. 3.45. What is the ratio of the ODA received (in %) in Vietnam in 1999 to that in 2004?
Your answer should be compact. 1.33. What is the ratio of the ODA received (in %) of High income in 1999 to that in 2005?
Give a very brief answer. 3.97. What is the ratio of the ODA received (in %) in Micronesia in 1999 to that in 2005?
Give a very brief answer. 1.15. What is the ratio of the ODA received (in %) in Syrian Arab Republic in 1999 to that in 2005?
Provide a short and direct response. 5.96. What is the ratio of the ODA received (in %) in Vietnam in 1999 to that in 2005?
Give a very brief answer. 1.49. What is the ratio of the ODA received (in %) of High income in 1999 to that in 2006?
Offer a very short reply. 3.75. What is the ratio of the ODA received (in %) of Micronesia in 1999 to that in 2006?
Your response must be concise. 1.15. What is the ratio of the ODA received (in %) of Syrian Arab Republic in 1999 to that in 2006?
Make the answer very short. 25.27. What is the ratio of the ODA received (in %) of Vietnam in 1999 to that in 2006?
Give a very brief answer. 1.78. What is the ratio of the ODA received (in %) in High income in 2000 to that in 2001?
Offer a terse response. 0.88. What is the ratio of the ODA received (in %) in Micronesia in 2000 to that in 2001?
Offer a terse response. 0.76. What is the ratio of the ODA received (in %) in Syrian Arab Republic in 2000 to that in 2001?
Provide a short and direct response. 1.14. What is the ratio of the ODA received (in %) of Vietnam in 2000 to that in 2001?
Keep it short and to the point. 1.23. What is the ratio of the ODA received (in %) of High income in 2000 to that in 2002?
Offer a very short reply. 1. What is the ratio of the ODA received (in %) in Micronesia in 2000 to that in 2002?
Your response must be concise. 0.93. What is the ratio of the ODA received (in %) in Syrian Arab Republic in 2000 to that in 2002?
Ensure brevity in your answer.  2.84. What is the ratio of the ODA received (in %) of Vietnam in 2000 to that in 2002?
Offer a very short reply. 1.48. What is the ratio of the ODA received (in %) of High income in 2000 to that in 2003?
Your answer should be compact. 0.99. What is the ratio of the ODA received (in %) of Micronesia in 2000 to that in 2003?
Offer a terse response. 0.92. What is the ratio of the ODA received (in %) of Syrian Arab Republic in 2000 to that in 2003?
Your answer should be compact. 1.48. What is the ratio of the ODA received (in %) of Vietnam in 2000 to that in 2003?
Provide a short and direct response. 1.2. What is the ratio of the ODA received (in %) of High income in 2000 to that in 2004?
Give a very brief answer. 1.21. What is the ratio of the ODA received (in %) in Micronesia in 2000 to that in 2004?
Give a very brief answer. 1.21. What is the ratio of the ODA received (in %) of Syrian Arab Republic in 2000 to that in 2004?
Give a very brief answer. 1.98. What is the ratio of the ODA received (in %) in Vietnam in 2000 to that in 2004?
Your answer should be compact. 1.33. What is the ratio of the ODA received (in %) in High income in 2000 to that in 2005?
Provide a short and direct response. 1.43. What is the ratio of the ODA received (in %) of Micronesia in 2000 to that in 2005?
Your answer should be compact. 1.03. What is the ratio of the ODA received (in %) in Syrian Arab Republic in 2000 to that in 2005?
Your answer should be compact. 3.43. What is the ratio of the ODA received (in %) of Vietnam in 2000 to that in 2005?
Provide a short and direct response. 1.5. What is the ratio of the ODA received (in %) of High income in 2000 to that in 2006?
Your answer should be very brief. 1.35. What is the ratio of the ODA received (in %) in Micronesia in 2000 to that in 2006?
Your response must be concise. 1.02. What is the ratio of the ODA received (in %) of Syrian Arab Republic in 2000 to that in 2006?
Keep it short and to the point. 14.54. What is the ratio of the ODA received (in %) in Vietnam in 2000 to that in 2006?
Offer a very short reply. 1.78. What is the ratio of the ODA received (in %) of High income in 2001 to that in 2002?
Give a very brief answer. 1.14. What is the ratio of the ODA received (in %) of Micronesia in 2001 to that in 2002?
Your response must be concise. 1.23. What is the ratio of the ODA received (in %) in Syrian Arab Republic in 2001 to that in 2002?
Give a very brief answer. 2.48. What is the ratio of the ODA received (in %) in Vietnam in 2001 to that in 2002?
Your answer should be very brief. 1.2. What is the ratio of the ODA received (in %) in High income in 2001 to that in 2003?
Ensure brevity in your answer.  1.12. What is the ratio of the ODA received (in %) of Micronesia in 2001 to that in 2003?
Your answer should be very brief. 1.22. What is the ratio of the ODA received (in %) of Syrian Arab Republic in 2001 to that in 2003?
Give a very brief answer. 1.29. What is the ratio of the ODA received (in %) of Vietnam in 2001 to that in 2003?
Your answer should be compact. 0.98. What is the ratio of the ODA received (in %) in High income in 2001 to that in 2004?
Your response must be concise. 1.38. What is the ratio of the ODA received (in %) in Micronesia in 2001 to that in 2004?
Keep it short and to the point. 1.61. What is the ratio of the ODA received (in %) of Syrian Arab Republic in 2001 to that in 2004?
Your answer should be compact. 1.73. What is the ratio of the ODA received (in %) in Vietnam in 2001 to that in 2004?
Your response must be concise. 1.08. What is the ratio of the ODA received (in %) of High income in 2001 to that in 2005?
Ensure brevity in your answer.  1.62. What is the ratio of the ODA received (in %) in Micronesia in 2001 to that in 2005?
Offer a very short reply. 1.36. What is the ratio of the ODA received (in %) of Syrian Arab Republic in 2001 to that in 2005?
Provide a succinct answer. 3. What is the ratio of the ODA received (in %) in Vietnam in 2001 to that in 2005?
Ensure brevity in your answer.  1.21. What is the ratio of the ODA received (in %) of High income in 2001 to that in 2006?
Make the answer very short. 1.53. What is the ratio of the ODA received (in %) of Micronesia in 2001 to that in 2006?
Ensure brevity in your answer.  1.35. What is the ratio of the ODA received (in %) of Syrian Arab Republic in 2001 to that in 2006?
Keep it short and to the point. 12.71. What is the ratio of the ODA received (in %) of Vietnam in 2001 to that in 2006?
Give a very brief answer. 1.45. What is the ratio of the ODA received (in %) of High income in 2002 to that in 2003?
Keep it short and to the point. 0.99. What is the ratio of the ODA received (in %) of Micronesia in 2002 to that in 2003?
Provide a short and direct response. 0.98. What is the ratio of the ODA received (in %) of Syrian Arab Republic in 2002 to that in 2003?
Offer a very short reply. 0.52. What is the ratio of the ODA received (in %) in Vietnam in 2002 to that in 2003?
Your answer should be very brief. 0.81. What is the ratio of the ODA received (in %) in High income in 2002 to that in 2004?
Your answer should be compact. 1.21. What is the ratio of the ODA received (in %) of Micronesia in 2002 to that in 2004?
Offer a terse response. 1.3. What is the ratio of the ODA received (in %) of Syrian Arab Republic in 2002 to that in 2004?
Make the answer very short. 0.7. What is the ratio of the ODA received (in %) of Vietnam in 2002 to that in 2004?
Ensure brevity in your answer.  0.9. What is the ratio of the ODA received (in %) in High income in 2002 to that in 2005?
Give a very brief answer. 1.43. What is the ratio of the ODA received (in %) in Micronesia in 2002 to that in 2005?
Provide a short and direct response. 1.1. What is the ratio of the ODA received (in %) in Syrian Arab Republic in 2002 to that in 2005?
Give a very brief answer. 1.21. What is the ratio of the ODA received (in %) of Vietnam in 2002 to that in 2005?
Ensure brevity in your answer.  1.01. What is the ratio of the ODA received (in %) in High income in 2002 to that in 2006?
Give a very brief answer. 1.35. What is the ratio of the ODA received (in %) in Micronesia in 2002 to that in 2006?
Give a very brief answer. 1.1. What is the ratio of the ODA received (in %) in Syrian Arab Republic in 2002 to that in 2006?
Keep it short and to the point. 5.13. What is the ratio of the ODA received (in %) of Vietnam in 2002 to that in 2006?
Give a very brief answer. 1.21. What is the ratio of the ODA received (in %) in High income in 2003 to that in 2004?
Make the answer very short. 1.23. What is the ratio of the ODA received (in %) in Micronesia in 2003 to that in 2004?
Make the answer very short. 1.32. What is the ratio of the ODA received (in %) in Syrian Arab Republic in 2003 to that in 2004?
Your answer should be very brief. 1.34. What is the ratio of the ODA received (in %) of Vietnam in 2003 to that in 2004?
Provide a succinct answer. 1.11. What is the ratio of the ODA received (in %) in High income in 2003 to that in 2005?
Offer a terse response. 1.45. What is the ratio of the ODA received (in %) of Micronesia in 2003 to that in 2005?
Offer a terse response. 1.12. What is the ratio of the ODA received (in %) in Syrian Arab Republic in 2003 to that in 2005?
Provide a succinct answer. 2.32. What is the ratio of the ODA received (in %) in Vietnam in 2003 to that in 2005?
Your answer should be compact. 1.24. What is the ratio of the ODA received (in %) of High income in 2003 to that in 2006?
Make the answer very short. 1.37. What is the ratio of the ODA received (in %) in Micronesia in 2003 to that in 2006?
Offer a very short reply. 1.11. What is the ratio of the ODA received (in %) of Syrian Arab Republic in 2003 to that in 2006?
Provide a short and direct response. 9.83. What is the ratio of the ODA received (in %) of Vietnam in 2003 to that in 2006?
Provide a succinct answer. 1.48. What is the ratio of the ODA received (in %) of High income in 2004 to that in 2005?
Offer a very short reply. 1.18. What is the ratio of the ODA received (in %) in Micronesia in 2004 to that in 2005?
Give a very brief answer. 0.85. What is the ratio of the ODA received (in %) in Syrian Arab Republic in 2004 to that in 2005?
Make the answer very short. 1.73. What is the ratio of the ODA received (in %) in Vietnam in 2004 to that in 2005?
Your response must be concise. 1.12. What is the ratio of the ODA received (in %) in High income in 2004 to that in 2006?
Offer a very short reply. 1.11. What is the ratio of the ODA received (in %) of Micronesia in 2004 to that in 2006?
Provide a short and direct response. 0.84. What is the ratio of the ODA received (in %) of Syrian Arab Republic in 2004 to that in 2006?
Your answer should be very brief. 7.33. What is the ratio of the ODA received (in %) in Vietnam in 2004 to that in 2006?
Give a very brief answer. 1.34. What is the ratio of the ODA received (in %) in High income in 2005 to that in 2006?
Offer a terse response. 0.95. What is the ratio of the ODA received (in %) of Syrian Arab Republic in 2005 to that in 2006?
Your answer should be very brief. 4.24. What is the ratio of the ODA received (in %) in Vietnam in 2005 to that in 2006?
Your answer should be compact. 1.19. What is the difference between the highest and the second highest ODA received (in %) of High income?
Make the answer very short. 0. What is the difference between the highest and the second highest ODA received (in %) in Micronesia?
Offer a very short reply. 8.55. What is the difference between the highest and the second highest ODA received (in %) of Syrian Arab Republic?
Ensure brevity in your answer.  0.64. What is the difference between the highest and the second highest ODA received (in %) of Vietnam?
Offer a terse response. 0.02. What is the difference between the highest and the lowest ODA received (in %) in High income?
Provide a short and direct response. 0. What is the difference between the highest and the lowest ODA received (in %) of Micronesia?
Your answer should be very brief. 21.14. What is the difference between the highest and the lowest ODA received (in %) of Syrian Arab Republic?
Ensure brevity in your answer.  1.44. What is the difference between the highest and the lowest ODA received (in %) in Vietnam?
Your response must be concise. 2.23. 